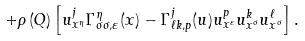Convert formula to latex. <formula><loc_0><loc_0><loc_500><loc_500>+ \rho \left ( Q \right ) \left [ u _ { x ^ { \eta } } ^ { j } \Gamma _ { \sigma \sigma , \varepsilon } ^ { \eta } ( x ) - \Gamma _ { \ell k , p } ^ { j } ( u ) u _ { x ^ { \varepsilon } } ^ { p } u _ { x ^ { \sigma } } ^ { k } u _ { x ^ { \sigma } } ^ { \ell } \right ] .</formula> 